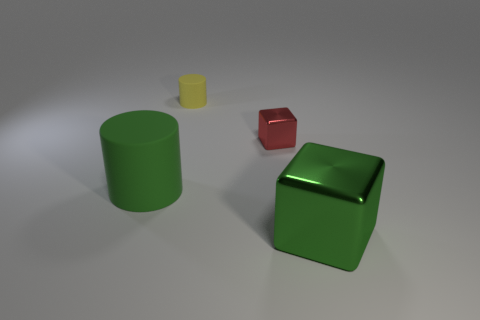Add 4 gray things. How many objects exist? 8 Add 2 blocks. How many blocks are left? 4 Add 3 brown balls. How many brown balls exist? 3 Subtract 0 cyan cubes. How many objects are left? 4 Subtract all large green cylinders. Subtract all small matte cylinders. How many objects are left? 2 